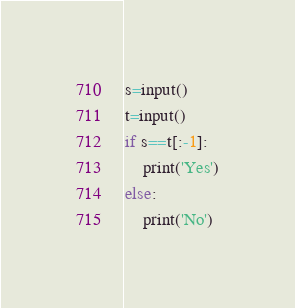<code> <loc_0><loc_0><loc_500><loc_500><_Python_>s=input()
t=input()
if s==t[:-1]:
    print('Yes')
else:
    print('No')</code> 